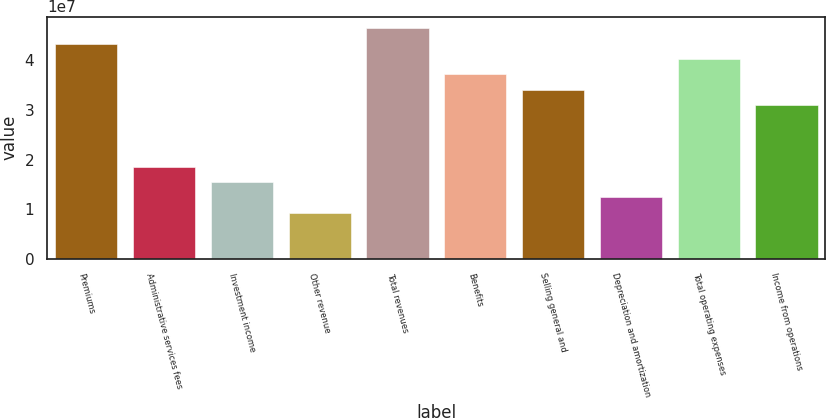<chart> <loc_0><loc_0><loc_500><loc_500><bar_chart><fcel>Premiums<fcel>Administrative services fees<fcel>Investment income<fcel>Other revenue<fcel>Total revenues<fcel>Benefits<fcel>Selling general and<fcel>Depreciation and amortization<fcel>Total operating expenses<fcel>Income from operations<nl><fcel>4.33446e+07<fcel>1.85763e+07<fcel>1.54802e+07<fcel>9.28813e+06<fcel>4.64406e+07<fcel>3.71525e+07<fcel>3.40565e+07<fcel>1.23842e+07<fcel>4.02485e+07<fcel>3.09604e+07<nl></chart> 